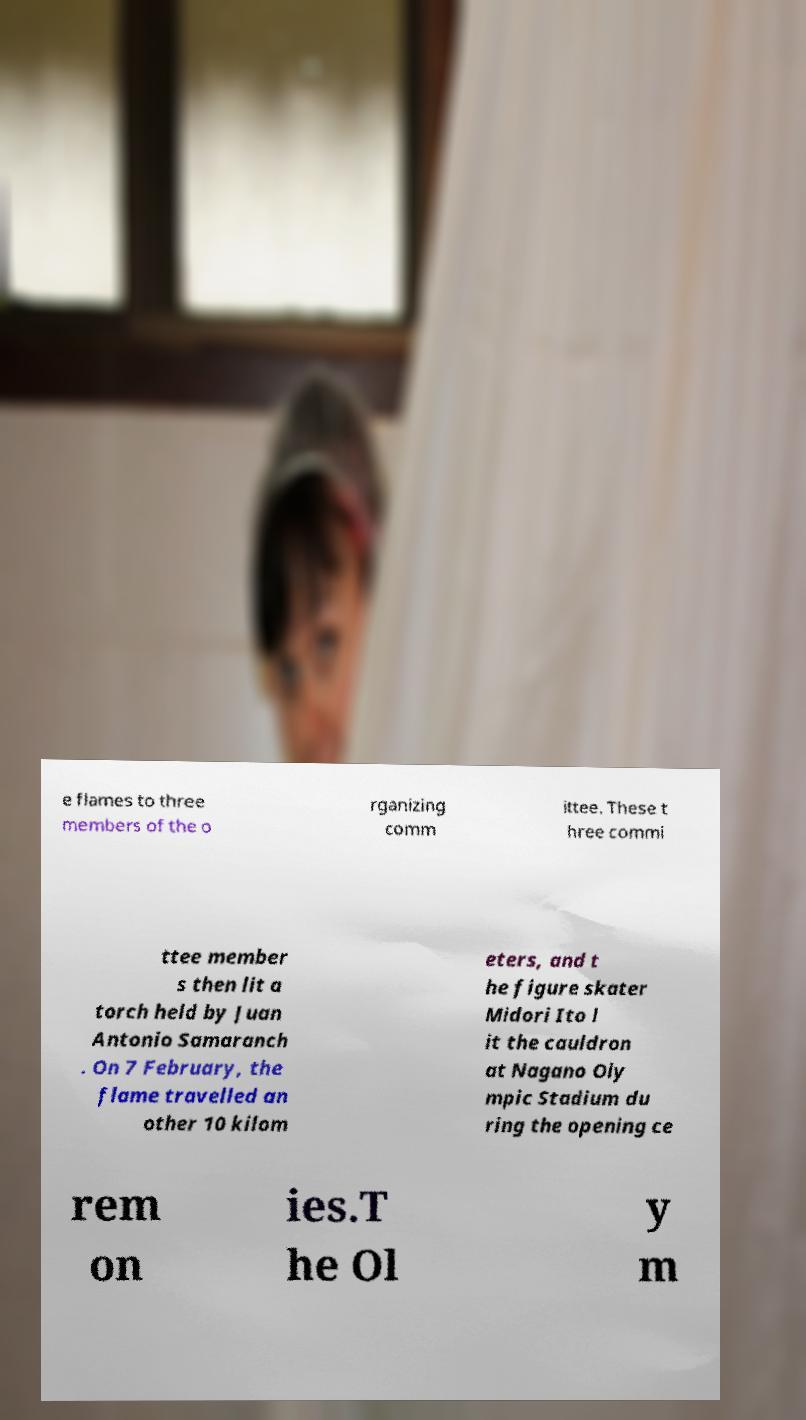For documentation purposes, I need the text within this image transcribed. Could you provide that? e flames to three members of the o rganizing comm ittee. These t hree commi ttee member s then lit a torch held by Juan Antonio Samaranch . On 7 February, the flame travelled an other 10 kilom eters, and t he figure skater Midori Ito l it the cauldron at Nagano Oly mpic Stadium du ring the opening ce rem on ies.T he Ol y m 